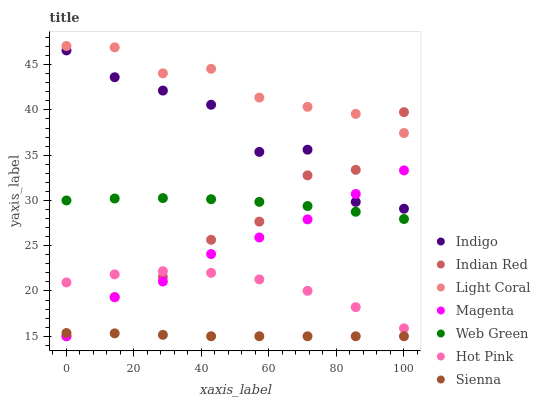Does Sienna have the minimum area under the curve?
Answer yes or no. Yes. Does Light Coral have the maximum area under the curve?
Answer yes or no. Yes. Does Indigo have the minimum area under the curve?
Answer yes or no. No. Does Indigo have the maximum area under the curve?
Answer yes or no. No. Is Sienna the smoothest?
Answer yes or no. Yes. Is Indigo the roughest?
Answer yes or no. Yes. Is Hot Pink the smoothest?
Answer yes or no. No. Is Hot Pink the roughest?
Answer yes or no. No. Does Sienna have the lowest value?
Answer yes or no. Yes. Does Indigo have the lowest value?
Answer yes or no. No. Does Light Coral have the highest value?
Answer yes or no. Yes. Does Indigo have the highest value?
Answer yes or no. No. Is Sienna less than Light Coral?
Answer yes or no. Yes. Is Light Coral greater than Magenta?
Answer yes or no. Yes. Does Indian Red intersect Indigo?
Answer yes or no. Yes. Is Indian Red less than Indigo?
Answer yes or no. No. Is Indian Red greater than Indigo?
Answer yes or no. No. Does Sienna intersect Light Coral?
Answer yes or no. No. 